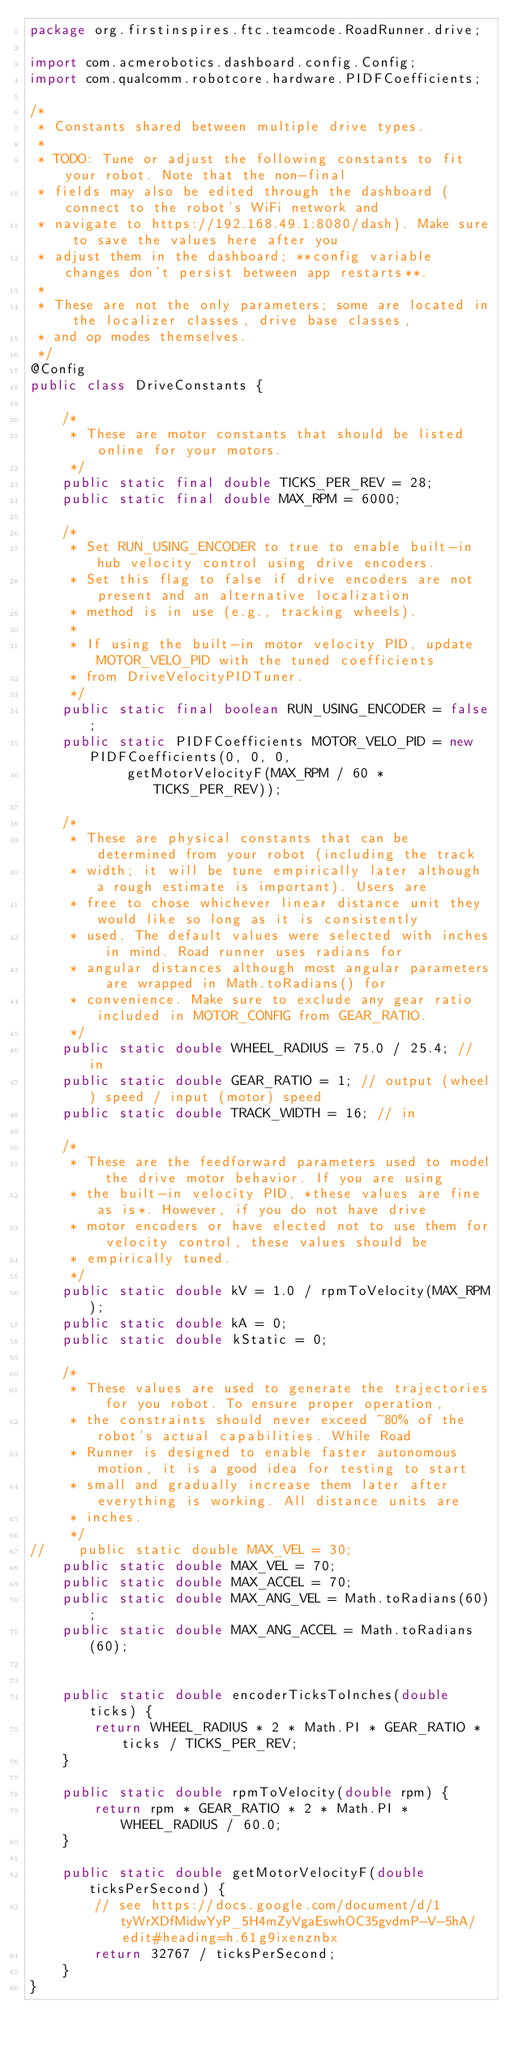<code> <loc_0><loc_0><loc_500><loc_500><_Java_>package org.firstinspires.ftc.teamcode.RoadRunner.drive;

import com.acmerobotics.dashboard.config.Config;
import com.qualcomm.robotcore.hardware.PIDFCoefficients;

/*
 * Constants shared between multiple drive types.
 *
 * TODO: Tune or adjust the following constants to fit your robot. Note that the non-final
 * fields may also be edited through the dashboard (connect to the robot's WiFi network and
 * navigate to https://192.168.49.1:8080/dash). Make sure to save the values here after you
 * adjust them in the dashboard; **config variable changes don't persist between app restarts**.
 *
 * These are not the only parameters; some are located in the localizer classes, drive base classes,
 * and op modes themselves.
 */
@Config
public class DriveConstants {

    /*
     * These are motor constants that should be listed online for your motors.
     */
    public static final double TICKS_PER_REV = 28;
    public static final double MAX_RPM = 6000;

    /*
     * Set RUN_USING_ENCODER to true to enable built-in hub velocity control using drive encoders.
     * Set this flag to false if drive encoders are not present and an alternative localization
     * method is in use (e.g., tracking wheels).
     *
     * If using the built-in motor velocity PID, update MOTOR_VELO_PID with the tuned coefficients
     * from DriveVelocityPIDTuner.
     */
    public static final boolean RUN_USING_ENCODER = false;
    public static PIDFCoefficients MOTOR_VELO_PID = new PIDFCoefficients(0, 0, 0,
            getMotorVelocityF(MAX_RPM / 60 * TICKS_PER_REV));

    /*
     * These are physical constants that can be determined from your robot (including the track
     * width; it will be tune empirically later although a rough estimate is important). Users are
     * free to chose whichever linear distance unit they would like so long as it is consistently
     * used. The default values were selected with inches in mind. Road runner uses radians for
     * angular distances although most angular parameters are wrapped in Math.toRadians() for
     * convenience. Make sure to exclude any gear ratio included in MOTOR_CONFIG from GEAR_RATIO.
     */
    public static double WHEEL_RADIUS = 75.0 / 25.4; // in
    public static double GEAR_RATIO = 1; // output (wheel) speed / input (motor) speed
    public static double TRACK_WIDTH = 16; // in

    /*
     * These are the feedforward parameters used to model the drive motor behavior. If you are using
     * the built-in velocity PID, *these values are fine as is*. However, if you do not have drive
     * motor encoders or have elected not to use them for velocity control, these values should be
     * empirically tuned.
     */
    public static double kV = 1.0 / rpmToVelocity(MAX_RPM);
    public static double kA = 0;
    public static double kStatic = 0;

    /*
     * These values are used to generate the trajectories for you robot. To ensure proper operation,
     * the constraints should never exceed ~80% of the robot's actual capabilities. While Road
     * Runner is designed to enable faster autonomous motion, it is a good idea for testing to start
     * small and gradually increase them later after everything is working. All distance units are
     * inches.
     */
//    public static double MAX_VEL = 30;
    public static double MAX_VEL = 70;
    public static double MAX_ACCEL = 70;
    public static double MAX_ANG_VEL = Math.toRadians(60);
    public static double MAX_ANG_ACCEL = Math.toRadians(60);


    public static double encoderTicksToInches(double ticks) {
        return WHEEL_RADIUS * 2 * Math.PI * GEAR_RATIO * ticks / TICKS_PER_REV;
    }

    public static double rpmToVelocity(double rpm) {
        return rpm * GEAR_RATIO * 2 * Math.PI * WHEEL_RADIUS / 60.0;
    }

    public static double getMotorVelocityF(double ticksPerSecond) {
        // see https://docs.google.com/document/d/1tyWrXDfMidwYyP_5H4mZyVgaEswhOC35gvdmP-V-5hA/edit#heading=h.61g9ixenznbx
        return 32767 / ticksPerSecond;
    }
}
</code> 